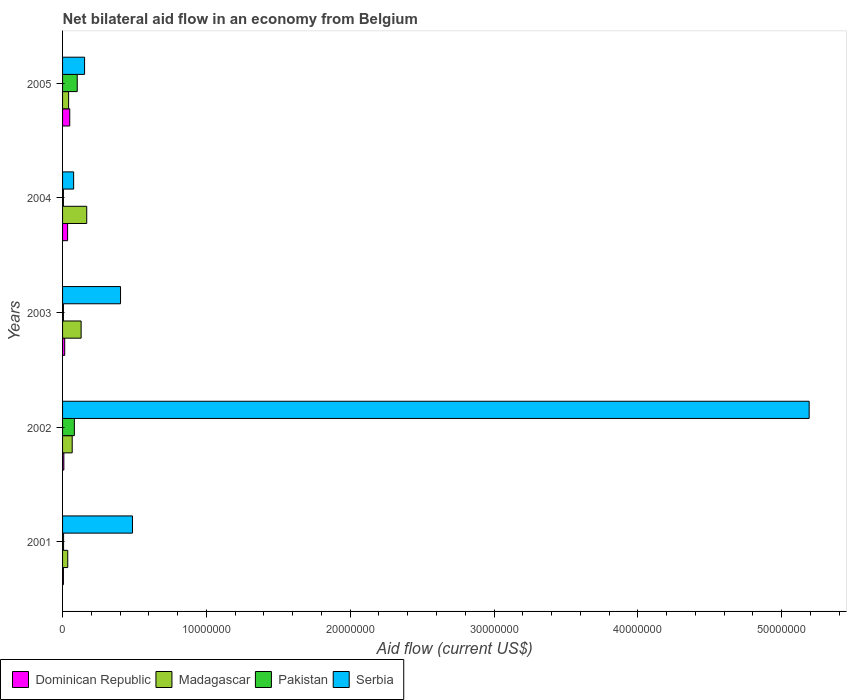How many bars are there on the 1st tick from the top?
Provide a short and direct response. 4. How many bars are there on the 4th tick from the bottom?
Offer a very short reply. 4. What is the label of the 4th group of bars from the top?
Keep it short and to the point. 2002. In how many cases, is the number of bars for a given year not equal to the number of legend labels?
Keep it short and to the point. 0. What is the net bilateral aid flow in Madagascar in 2002?
Provide a succinct answer. 6.70e+05. Across all years, what is the maximum net bilateral aid flow in Madagascar?
Ensure brevity in your answer.  1.68e+06. Across all years, what is the minimum net bilateral aid flow in Serbia?
Your answer should be compact. 7.70e+05. In which year was the net bilateral aid flow in Madagascar maximum?
Your response must be concise. 2004. In which year was the net bilateral aid flow in Pakistan minimum?
Make the answer very short. 2003. What is the total net bilateral aid flow in Madagascar in the graph?
Make the answer very short. 4.42e+06. What is the difference between the net bilateral aid flow in Dominican Republic in 2004 and the net bilateral aid flow in Serbia in 2001?
Ensure brevity in your answer.  -4.51e+06. What is the average net bilateral aid flow in Madagascar per year?
Offer a very short reply. 8.84e+05. What is the ratio of the net bilateral aid flow in Serbia in 2003 to that in 2005?
Provide a succinct answer. 2.63. Is the net bilateral aid flow in Madagascar in 2001 less than that in 2003?
Ensure brevity in your answer.  Yes. What is the difference between the highest and the second highest net bilateral aid flow in Serbia?
Your answer should be very brief. 4.70e+07. What is the difference between the highest and the lowest net bilateral aid flow in Serbia?
Ensure brevity in your answer.  5.11e+07. Is the sum of the net bilateral aid flow in Madagascar in 2001 and 2003 greater than the maximum net bilateral aid flow in Dominican Republic across all years?
Provide a succinct answer. Yes. Is it the case that in every year, the sum of the net bilateral aid flow in Madagascar and net bilateral aid flow in Pakistan is greater than the sum of net bilateral aid flow in Dominican Republic and net bilateral aid flow in Serbia?
Offer a very short reply. Yes. What does the 1st bar from the top in 2001 represents?
Ensure brevity in your answer.  Serbia. What does the 3rd bar from the bottom in 2002 represents?
Provide a short and direct response. Pakistan. Are all the bars in the graph horizontal?
Your answer should be compact. Yes. Does the graph contain grids?
Provide a short and direct response. No. How many legend labels are there?
Provide a short and direct response. 4. What is the title of the graph?
Your response must be concise. Net bilateral aid flow in an economy from Belgium. Does "Costa Rica" appear as one of the legend labels in the graph?
Provide a short and direct response. No. What is the label or title of the Y-axis?
Your answer should be very brief. Years. What is the Aid flow (current US$) in Madagascar in 2001?
Keep it short and to the point. 3.60e+05. What is the Aid flow (current US$) of Pakistan in 2001?
Make the answer very short. 7.00e+04. What is the Aid flow (current US$) of Serbia in 2001?
Keep it short and to the point. 4.86e+06. What is the Aid flow (current US$) in Madagascar in 2002?
Give a very brief answer. 6.70e+05. What is the Aid flow (current US$) of Pakistan in 2002?
Your answer should be compact. 8.20e+05. What is the Aid flow (current US$) of Serbia in 2002?
Provide a short and direct response. 5.19e+07. What is the Aid flow (current US$) of Dominican Republic in 2003?
Your answer should be very brief. 1.50e+05. What is the Aid flow (current US$) of Madagascar in 2003?
Make the answer very short. 1.29e+06. What is the Aid flow (current US$) of Pakistan in 2003?
Your answer should be compact. 6.00e+04. What is the Aid flow (current US$) of Serbia in 2003?
Ensure brevity in your answer.  4.03e+06. What is the Aid flow (current US$) in Madagascar in 2004?
Your answer should be compact. 1.68e+06. What is the Aid flow (current US$) in Serbia in 2004?
Give a very brief answer. 7.70e+05. What is the Aid flow (current US$) of Pakistan in 2005?
Offer a terse response. 1.02e+06. What is the Aid flow (current US$) of Serbia in 2005?
Provide a succinct answer. 1.53e+06. Across all years, what is the maximum Aid flow (current US$) in Dominican Republic?
Keep it short and to the point. 5.00e+05. Across all years, what is the maximum Aid flow (current US$) of Madagascar?
Your answer should be very brief. 1.68e+06. Across all years, what is the maximum Aid flow (current US$) of Pakistan?
Keep it short and to the point. 1.02e+06. Across all years, what is the maximum Aid flow (current US$) in Serbia?
Your answer should be very brief. 5.19e+07. Across all years, what is the minimum Aid flow (current US$) in Serbia?
Keep it short and to the point. 7.70e+05. What is the total Aid flow (current US$) in Dominican Republic in the graph?
Provide a succinct answer. 1.15e+06. What is the total Aid flow (current US$) of Madagascar in the graph?
Your response must be concise. 4.42e+06. What is the total Aid flow (current US$) in Pakistan in the graph?
Provide a succinct answer. 2.03e+06. What is the total Aid flow (current US$) in Serbia in the graph?
Make the answer very short. 6.31e+07. What is the difference between the Aid flow (current US$) in Dominican Republic in 2001 and that in 2002?
Offer a very short reply. -3.00e+04. What is the difference between the Aid flow (current US$) of Madagascar in 2001 and that in 2002?
Your response must be concise. -3.10e+05. What is the difference between the Aid flow (current US$) in Pakistan in 2001 and that in 2002?
Ensure brevity in your answer.  -7.50e+05. What is the difference between the Aid flow (current US$) of Serbia in 2001 and that in 2002?
Keep it short and to the point. -4.70e+07. What is the difference between the Aid flow (current US$) in Dominican Republic in 2001 and that in 2003?
Make the answer very short. -9.00e+04. What is the difference between the Aid flow (current US$) of Madagascar in 2001 and that in 2003?
Give a very brief answer. -9.30e+05. What is the difference between the Aid flow (current US$) in Pakistan in 2001 and that in 2003?
Offer a terse response. 10000. What is the difference between the Aid flow (current US$) of Serbia in 2001 and that in 2003?
Make the answer very short. 8.30e+05. What is the difference between the Aid flow (current US$) in Dominican Republic in 2001 and that in 2004?
Make the answer very short. -2.90e+05. What is the difference between the Aid flow (current US$) of Madagascar in 2001 and that in 2004?
Offer a very short reply. -1.32e+06. What is the difference between the Aid flow (current US$) in Pakistan in 2001 and that in 2004?
Keep it short and to the point. 10000. What is the difference between the Aid flow (current US$) in Serbia in 2001 and that in 2004?
Give a very brief answer. 4.09e+06. What is the difference between the Aid flow (current US$) of Dominican Republic in 2001 and that in 2005?
Offer a very short reply. -4.40e+05. What is the difference between the Aid flow (current US$) in Madagascar in 2001 and that in 2005?
Ensure brevity in your answer.  -6.00e+04. What is the difference between the Aid flow (current US$) in Pakistan in 2001 and that in 2005?
Give a very brief answer. -9.50e+05. What is the difference between the Aid flow (current US$) in Serbia in 2001 and that in 2005?
Make the answer very short. 3.33e+06. What is the difference between the Aid flow (current US$) of Dominican Republic in 2002 and that in 2003?
Keep it short and to the point. -6.00e+04. What is the difference between the Aid flow (current US$) of Madagascar in 2002 and that in 2003?
Offer a terse response. -6.20e+05. What is the difference between the Aid flow (current US$) of Pakistan in 2002 and that in 2003?
Ensure brevity in your answer.  7.60e+05. What is the difference between the Aid flow (current US$) of Serbia in 2002 and that in 2003?
Make the answer very short. 4.79e+07. What is the difference between the Aid flow (current US$) in Madagascar in 2002 and that in 2004?
Your answer should be very brief. -1.01e+06. What is the difference between the Aid flow (current US$) in Pakistan in 2002 and that in 2004?
Keep it short and to the point. 7.60e+05. What is the difference between the Aid flow (current US$) in Serbia in 2002 and that in 2004?
Provide a succinct answer. 5.11e+07. What is the difference between the Aid flow (current US$) in Dominican Republic in 2002 and that in 2005?
Your answer should be very brief. -4.10e+05. What is the difference between the Aid flow (current US$) of Madagascar in 2002 and that in 2005?
Provide a short and direct response. 2.50e+05. What is the difference between the Aid flow (current US$) of Serbia in 2002 and that in 2005?
Offer a very short reply. 5.04e+07. What is the difference between the Aid flow (current US$) of Dominican Republic in 2003 and that in 2004?
Give a very brief answer. -2.00e+05. What is the difference between the Aid flow (current US$) of Madagascar in 2003 and that in 2004?
Ensure brevity in your answer.  -3.90e+05. What is the difference between the Aid flow (current US$) in Pakistan in 2003 and that in 2004?
Ensure brevity in your answer.  0. What is the difference between the Aid flow (current US$) in Serbia in 2003 and that in 2004?
Ensure brevity in your answer.  3.26e+06. What is the difference between the Aid flow (current US$) of Dominican Republic in 2003 and that in 2005?
Provide a short and direct response. -3.50e+05. What is the difference between the Aid flow (current US$) in Madagascar in 2003 and that in 2005?
Offer a terse response. 8.70e+05. What is the difference between the Aid flow (current US$) of Pakistan in 2003 and that in 2005?
Your answer should be compact. -9.60e+05. What is the difference between the Aid flow (current US$) of Serbia in 2003 and that in 2005?
Your response must be concise. 2.50e+06. What is the difference between the Aid flow (current US$) of Madagascar in 2004 and that in 2005?
Make the answer very short. 1.26e+06. What is the difference between the Aid flow (current US$) of Pakistan in 2004 and that in 2005?
Provide a succinct answer. -9.60e+05. What is the difference between the Aid flow (current US$) in Serbia in 2004 and that in 2005?
Provide a succinct answer. -7.60e+05. What is the difference between the Aid flow (current US$) of Dominican Republic in 2001 and the Aid flow (current US$) of Madagascar in 2002?
Your answer should be very brief. -6.10e+05. What is the difference between the Aid flow (current US$) in Dominican Republic in 2001 and the Aid flow (current US$) in Pakistan in 2002?
Your response must be concise. -7.60e+05. What is the difference between the Aid flow (current US$) of Dominican Republic in 2001 and the Aid flow (current US$) of Serbia in 2002?
Offer a terse response. -5.18e+07. What is the difference between the Aid flow (current US$) of Madagascar in 2001 and the Aid flow (current US$) of Pakistan in 2002?
Your answer should be compact. -4.60e+05. What is the difference between the Aid flow (current US$) in Madagascar in 2001 and the Aid flow (current US$) in Serbia in 2002?
Offer a very short reply. -5.16e+07. What is the difference between the Aid flow (current US$) in Pakistan in 2001 and the Aid flow (current US$) in Serbia in 2002?
Keep it short and to the point. -5.18e+07. What is the difference between the Aid flow (current US$) of Dominican Republic in 2001 and the Aid flow (current US$) of Madagascar in 2003?
Offer a terse response. -1.23e+06. What is the difference between the Aid flow (current US$) in Dominican Republic in 2001 and the Aid flow (current US$) in Pakistan in 2003?
Give a very brief answer. 0. What is the difference between the Aid flow (current US$) in Dominican Republic in 2001 and the Aid flow (current US$) in Serbia in 2003?
Offer a terse response. -3.97e+06. What is the difference between the Aid flow (current US$) in Madagascar in 2001 and the Aid flow (current US$) in Serbia in 2003?
Provide a succinct answer. -3.67e+06. What is the difference between the Aid flow (current US$) of Pakistan in 2001 and the Aid flow (current US$) of Serbia in 2003?
Provide a short and direct response. -3.96e+06. What is the difference between the Aid flow (current US$) in Dominican Republic in 2001 and the Aid flow (current US$) in Madagascar in 2004?
Your answer should be compact. -1.62e+06. What is the difference between the Aid flow (current US$) in Dominican Republic in 2001 and the Aid flow (current US$) in Serbia in 2004?
Your response must be concise. -7.10e+05. What is the difference between the Aid flow (current US$) in Madagascar in 2001 and the Aid flow (current US$) in Serbia in 2004?
Give a very brief answer. -4.10e+05. What is the difference between the Aid flow (current US$) in Pakistan in 2001 and the Aid flow (current US$) in Serbia in 2004?
Your answer should be very brief. -7.00e+05. What is the difference between the Aid flow (current US$) of Dominican Republic in 2001 and the Aid flow (current US$) of Madagascar in 2005?
Your answer should be compact. -3.60e+05. What is the difference between the Aid flow (current US$) of Dominican Republic in 2001 and the Aid flow (current US$) of Pakistan in 2005?
Your response must be concise. -9.60e+05. What is the difference between the Aid flow (current US$) of Dominican Republic in 2001 and the Aid flow (current US$) of Serbia in 2005?
Your answer should be very brief. -1.47e+06. What is the difference between the Aid flow (current US$) in Madagascar in 2001 and the Aid flow (current US$) in Pakistan in 2005?
Provide a succinct answer. -6.60e+05. What is the difference between the Aid flow (current US$) of Madagascar in 2001 and the Aid flow (current US$) of Serbia in 2005?
Provide a succinct answer. -1.17e+06. What is the difference between the Aid flow (current US$) in Pakistan in 2001 and the Aid flow (current US$) in Serbia in 2005?
Your answer should be very brief. -1.46e+06. What is the difference between the Aid flow (current US$) of Dominican Republic in 2002 and the Aid flow (current US$) of Madagascar in 2003?
Offer a very short reply. -1.20e+06. What is the difference between the Aid flow (current US$) of Dominican Republic in 2002 and the Aid flow (current US$) of Serbia in 2003?
Provide a short and direct response. -3.94e+06. What is the difference between the Aid flow (current US$) in Madagascar in 2002 and the Aid flow (current US$) in Serbia in 2003?
Provide a succinct answer. -3.36e+06. What is the difference between the Aid flow (current US$) of Pakistan in 2002 and the Aid flow (current US$) of Serbia in 2003?
Ensure brevity in your answer.  -3.21e+06. What is the difference between the Aid flow (current US$) of Dominican Republic in 2002 and the Aid flow (current US$) of Madagascar in 2004?
Your response must be concise. -1.59e+06. What is the difference between the Aid flow (current US$) of Dominican Republic in 2002 and the Aid flow (current US$) of Pakistan in 2004?
Give a very brief answer. 3.00e+04. What is the difference between the Aid flow (current US$) of Dominican Republic in 2002 and the Aid flow (current US$) of Serbia in 2004?
Provide a succinct answer. -6.80e+05. What is the difference between the Aid flow (current US$) of Madagascar in 2002 and the Aid flow (current US$) of Serbia in 2004?
Provide a succinct answer. -1.00e+05. What is the difference between the Aid flow (current US$) of Dominican Republic in 2002 and the Aid flow (current US$) of Madagascar in 2005?
Your answer should be compact. -3.30e+05. What is the difference between the Aid flow (current US$) of Dominican Republic in 2002 and the Aid flow (current US$) of Pakistan in 2005?
Keep it short and to the point. -9.30e+05. What is the difference between the Aid flow (current US$) in Dominican Republic in 2002 and the Aid flow (current US$) in Serbia in 2005?
Ensure brevity in your answer.  -1.44e+06. What is the difference between the Aid flow (current US$) of Madagascar in 2002 and the Aid flow (current US$) of Pakistan in 2005?
Offer a very short reply. -3.50e+05. What is the difference between the Aid flow (current US$) in Madagascar in 2002 and the Aid flow (current US$) in Serbia in 2005?
Provide a short and direct response. -8.60e+05. What is the difference between the Aid flow (current US$) in Pakistan in 2002 and the Aid flow (current US$) in Serbia in 2005?
Offer a very short reply. -7.10e+05. What is the difference between the Aid flow (current US$) in Dominican Republic in 2003 and the Aid flow (current US$) in Madagascar in 2004?
Offer a terse response. -1.53e+06. What is the difference between the Aid flow (current US$) in Dominican Republic in 2003 and the Aid flow (current US$) in Serbia in 2004?
Keep it short and to the point. -6.20e+05. What is the difference between the Aid flow (current US$) of Madagascar in 2003 and the Aid flow (current US$) of Pakistan in 2004?
Your response must be concise. 1.23e+06. What is the difference between the Aid flow (current US$) in Madagascar in 2003 and the Aid flow (current US$) in Serbia in 2004?
Offer a very short reply. 5.20e+05. What is the difference between the Aid flow (current US$) of Pakistan in 2003 and the Aid flow (current US$) of Serbia in 2004?
Offer a terse response. -7.10e+05. What is the difference between the Aid flow (current US$) in Dominican Republic in 2003 and the Aid flow (current US$) in Pakistan in 2005?
Your answer should be compact. -8.70e+05. What is the difference between the Aid flow (current US$) in Dominican Republic in 2003 and the Aid flow (current US$) in Serbia in 2005?
Offer a very short reply. -1.38e+06. What is the difference between the Aid flow (current US$) of Madagascar in 2003 and the Aid flow (current US$) of Pakistan in 2005?
Keep it short and to the point. 2.70e+05. What is the difference between the Aid flow (current US$) in Madagascar in 2003 and the Aid flow (current US$) in Serbia in 2005?
Give a very brief answer. -2.40e+05. What is the difference between the Aid flow (current US$) in Pakistan in 2003 and the Aid flow (current US$) in Serbia in 2005?
Make the answer very short. -1.47e+06. What is the difference between the Aid flow (current US$) in Dominican Republic in 2004 and the Aid flow (current US$) in Madagascar in 2005?
Provide a short and direct response. -7.00e+04. What is the difference between the Aid flow (current US$) of Dominican Republic in 2004 and the Aid flow (current US$) of Pakistan in 2005?
Provide a short and direct response. -6.70e+05. What is the difference between the Aid flow (current US$) of Dominican Republic in 2004 and the Aid flow (current US$) of Serbia in 2005?
Your answer should be compact. -1.18e+06. What is the difference between the Aid flow (current US$) of Madagascar in 2004 and the Aid flow (current US$) of Serbia in 2005?
Make the answer very short. 1.50e+05. What is the difference between the Aid flow (current US$) of Pakistan in 2004 and the Aid flow (current US$) of Serbia in 2005?
Your answer should be compact. -1.47e+06. What is the average Aid flow (current US$) of Madagascar per year?
Your answer should be compact. 8.84e+05. What is the average Aid flow (current US$) in Pakistan per year?
Offer a terse response. 4.06e+05. What is the average Aid flow (current US$) of Serbia per year?
Keep it short and to the point. 1.26e+07. In the year 2001, what is the difference between the Aid flow (current US$) of Dominican Republic and Aid flow (current US$) of Madagascar?
Keep it short and to the point. -3.00e+05. In the year 2001, what is the difference between the Aid flow (current US$) of Dominican Republic and Aid flow (current US$) of Pakistan?
Keep it short and to the point. -10000. In the year 2001, what is the difference between the Aid flow (current US$) of Dominican Republic and Aid flow (current US$) of Serbia?
Provide a short and direct response. -4.80e+06. In the year 2001, what is the difference between the Aid flow (current US$) in Madagascar and Aid flow (current US$) in Serbia?
Offer a terse response. -4.50e+06. In the year 2001, what is the difference between the Aid flow (current US$) in Pakistan and Aid flow (current US$) in Serbia?
Your answer should be compact. -4.79e+06. In the year 2002, what is the difference between the Aid flow (current US$) in Dominican Republic and Aid flow (current US$) in Madagascar?
Make the answer very short. -5.80e+05. In the year 2002, what is the difference between the Aid flow (current US$) of Dominican Republic and Aid flow (current US$) of Pakistan?
Make the answer very short. -7.30e+05. In the year 2002, what is the difference between the Aid flow (current US$) in Dominican Republic and Aid flow (current US$) in Serbia?
Offer a terse response. -5.18e+07. In the year 2002, what is the difference between the Aid flow (current US$) of Madagascar and Aid flow (current US$) of Pakistan?
Give a very brief answer. -1.50e+05. In the year 2002, what is the difference between the Aid flow (current US$) of Madagascar and Aid flow (current US$) of Serbia?
Your response must be concise. -5.12e+07. In the year 2002, what is the difference between the Aid flow (current US$) of Pakistan and Aid flow (current US$) of Serbia?
Make the answer very short. -5.11e+07. In the year 2003, what is the difference between the Aid flow (current US$) in Dominican Republic and Aid flow (current US$) in Madagascar?
Ensure brevity in your answer.  -1.14e+06. In the year 2003, what is the difference between the Aid flow (current US$) of Dominican Republic and Aid flow (current US$) of Serbia?
Provide a short and direct response. -3.88e+06. In the year 2003, what is the difference between the Aid flow (current US$) of Madagascar and Aid flow (current US$) of Pakistan?
Provide a short and direct response. 1.23e+06. In the year 2003, what is the difference between the Aid flow (current US$) of Madagascar and Aid flow (current US$) of Serbia?
Offer a terse response. -2.74e+06. In the year 2003, what is the difference between the Aid flow (current US$) in Pakistan and Aid flow (current US$) in Serbia?
Offer a terse response. -3.97e+06. In the year 2004, what is the difference between the Aid flow (current US$) of Dominican Republic and Aid flow (current US$) of Madagascar?
Your response must be concise. -1.33e+06. In the year 2004, what is the difference between the Aid flow (current US$) of Dominican Republic and Aid flow (current US$) of Serbia?
Make the answer very short. -4.20e+05. In the year 2004, what is the difference between the Aid flow (current US$) in Madagascar and Aid flow (current US$) in Pakistan?
Offer a terse response. 1.62e+06. In the year 2004, what is the difference between the Aid flow (current US$) in Madagascar and Aid flow (current US$) in Serbia?
Provide a short and direct response. 9.10e+05. In the year 2004, what is the difference between the Aid flow (current US$) of Pakistan and Aid flow (current US$) of Serbia?
Your answer should be very brief. -7.10e+05. In the year 2005, what is the difference between the Aid flow (current US$) of Dominican Republic and Aid flow (current US$) of Madagascar?
Your answer should be very brief. 8.00e+04. In the year 2005, what is the difference between the Aid flow (current US$) in Dominican Republic and Aid flow (current US$) in Pakistan?
Your response must be concise. -5.20e+05. In the year 2005, what is the difference between the Aid flow (current US$) in Dominican Republic and Aid flow (current US$) in Serbia?
Your answer should be compact. -1.03e+06. In the year 2005, what is the difference between the Aid flow (current US$) of Madagascar and Aid flow (current US$) of Pakistan?
Your answer should be very brief. -6.00e+05. In the year 2005, what is the difference between the Aid flow (current US$) of Madagascar and Aid flow (current US$) of Serbia?
Make the answer very short. -1.11e+06. In the year 2005, what is the difference between the Aid flow (current US$) in Pakistan and Aid flow (current US$) in Serbia?
Make the answer very short. -5.10e+05. What is the ratio of the Aid flow (current US$) in Madagascar in 2001 to that in 2002?
Give a very brief answer. 0.54. What is the ratio of the Aid flow (current US$) in Pakistan in 2001 to that in 2002?
Keep it short and to the point. 0.09. What is the ratio of the Aid flow (current US$) in Serbia in 2001 to that in 2002?
Ensure brevity in your answer.  0.09. What is the ratio of the Aid flow (current US$) in Madagascar in 2001 to that in 2003?
Offer a terse response. 0.28. What is the ratio of the Aid flow (current US$) in Serbia in 2001 to that in 2003?
Provide a succinct answer. 1.21. What is the ratio of the Aid flow (current US$) of Dominican Republic in 2001 to that in 2004?
Offer a very short reply. 0.17. What is the ratio of the Aid flow (current US$) in Madagascar in 2001 to that in 2004?
Your answer should be very brief. 0.21. What is the ratio of the Aid flow (current US$) of Serbia in 2001 to that in 2004?
Your answer should be very brief. 6.31. What is the ratio of the Aid flow (current US$) of Dominican Republic in 2001 to that in 2005?
Provide a succinct answer. 0.12. What is the ratio of the Aid flow (current US$) in Madagascar in 2001 to that in 2005?
Offer a very short reply. 0.86. What is the ratio of the Aid flow (current US$) of Pakistan in 2001 to that in 2005?
Make the answer very short. 0.07. What is the ratio of the Aid flow (current US$) of Serbia in 2001 to that in 2005?
Provide a short and direct response. 3.18. What is the ratio of the Aid flow (current US$) of Dominican Republic in 2002 to that in 2003?
Offer a terse response. 0.6. What is the ratio of the Aid flow (current US$) in Madagascar in 2002 to that in 2003?
Ensure brevity in your answer.  0.52. What is the ratio of the Aid flow (current US$) of Pakistan in 2002 to that in 2003?
Offer a terse response. 13.67. What is the ratio of the Aid flow (current US$) of Serbia in 2002 to that in 2003?
Provide a succinct answer. 12.88. What is the ratio of the Aid flow (current US$) in Dominican Republic in 2002 to that in 2004?
Your response must be concise. 0.26. What is the ratio of the Aid flow (current US$) of Madagascar in 2002 to that in 2004?
Offer a very short reply. 0.4. What is the ratio of the Aid flow (current US$) of Pakistan in 2002 to that in 2004?
Provide a short and direct response. 13.67. What is the ratio of the Aid flow (current US$) in Serbia in 2002 to that in 2004?
Offer a very short reply. 67.42. What is the ratio of the Aid flow (current US$) of Dominican Republic in 2002 to that in 2005?
Your response must be concise. 0.18. What is the ratio of the Aid flow (current US$) in Madagascar in 2002 to that in 2005?
Keep it short and to the point. 1.6. What is the ratio of the Aid flow (current US$) in Pakistan in 2002 to that in 2005?
Your answer should be very brief. 0.8. What is the ratio of the Aid flow (current US$) in Serbia in 2002 to that in 2005?
Offer a terse response. 33.93. What is the ratio of the Aid flow (current US$) of Dominican Republic in 2003 to that in 2004?
Your response must be concise. 0.43. What is the ratio of the Aid flow (current US$) in Madagascar in 2003 to that in 2004?
Provide a succinct answer. 0.77. What is the ratio of the Aid flow (current US$) in Pakistan in 2003 to that in 2004?
Offer a terse response. 1. What is the ratio of the Aid flow (current US$) of Serbia in 2003 to that in 2004?
Ensure brevity in your answer.  5.23. What is the ratio of the Aid flow (current US$) of Dominican Republic in 2003 to that in 2005?
Provide a succinct answer. 0.3. What is the ratio of the Aid flow (current US$) in Madagascar in 2003 to that in 2005?
Offer a very short reply. 3.07. What is the ratio of the Aid flow (current US$) of Pakistan in 2003 to that in 2005?
Your answer should be compact. 0.06. What is the ratio of the Aid flow (current US$) of Serbia in 2003 to that in 2005?
Your answer should be very brief. 2.63. What is the ratio of the Aid flow (current US$) of Dominican Republic in 2004 to that in 2005?
Offer a very short reply. 0.7. What is the ratio of the Aid flow (current US$) of Madagascar in 2004 to that in 2005?
Ensure brevity in your answer.  4. What is the ratio of the Aid flow (current US$) of Pakistan in 2004 to that in 2005?
Provide a succinct answer. 0.06. What is the ratio of the Aid flow (current US$) of Serbia in 2004 to that in 2005?
Make the answer very short. 0.5. What is the difference between the highest and the second highest Aid flow (current US$) of Dominican Republic?
Ensure brevity in your answer.  1.50e+05. What is the difference between the highest and the second highest Aid flow (current US$) of Serbia?
Ensure brevity in your answer.  4.70e+07. What is the difference between the highest and the lowest Aid flow (current US$) in Dominican Republic?
Your answer should be compact. 4.40e+05. What is the difference between the highest and the lowest Aid flow (current US$) of Madagascar?
Give a very brief answer. 1.32e+06. What is the difference between the highest and the lowest Aid flow (current US$) in Pakistan?
Provide a short and direct response. 9.60e+05. What is the difference between the highest and the lowest Aid flow (current US$) in Serbia?
Your answer should be very brief. 5.11e+07. 